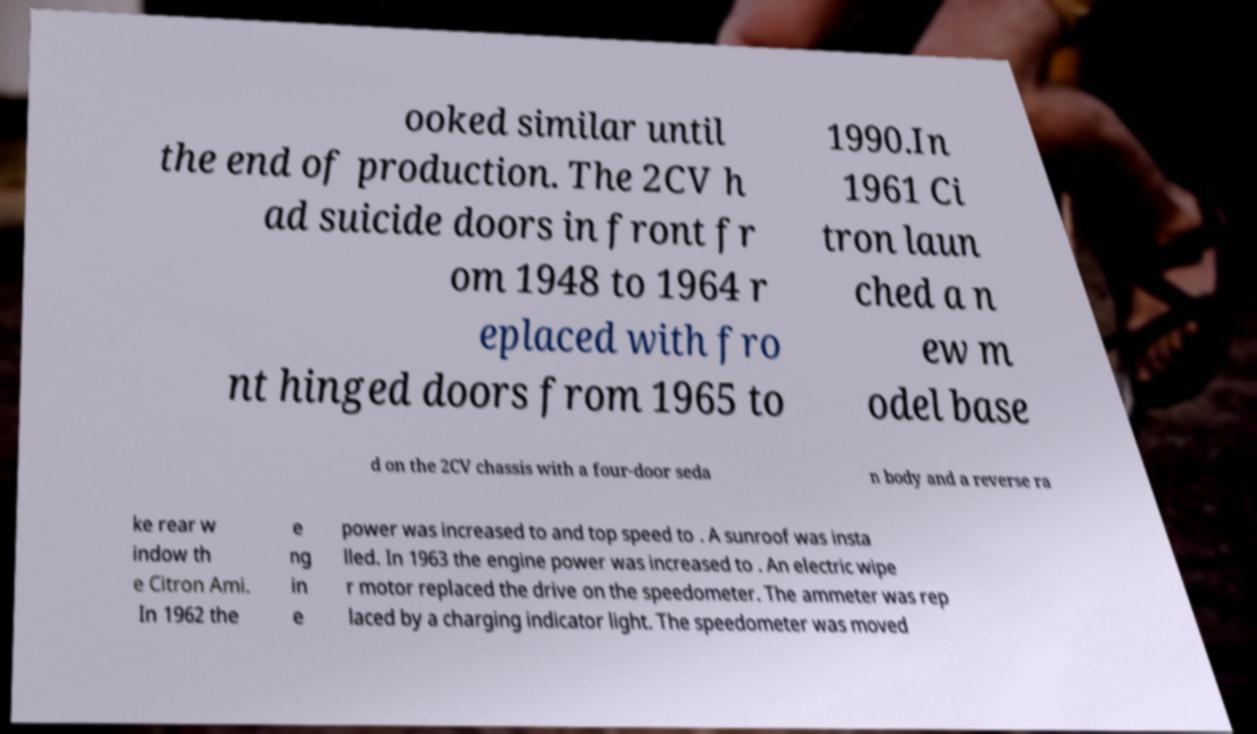Please identify and transcribe the text found in this image. ooked similar until the end of production. The 2CV h ad suicide doors in front fr om 1948 to 1964 r eplaced with fro nt hinged doors from 1965 to 1990.In 1961 Ci tron laun ched a n ew m odel base d on the 2CV chassis with a four-door seda n body and a reverse ra ke rear w indow th e Citron Ami. In 1962 the e ng in e power was increased to and top speed to . A sunroof was insta lled. In 1963 the engine power was increased to . An electric wipe r motor replaced the drive on the speedometer. The ammeter was rep laced by a charging indicator light. The speedometer was moved 